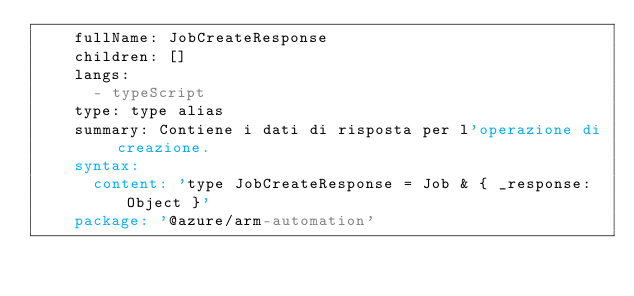Convert code to text. <code><loc_0><loc_0><loc_500><loc_500><_YAML_>    fullName: JobCreateResponse
    children: []
    langs:
      - typeScript
    type: type alias
    summary: Contiene i dati di risposta per l'operazione di creazione.
    syntax:
      content: 'type JobCreateResponse = Job & { _response: Object }'
    package: '@azure/arm-automation'</code> 